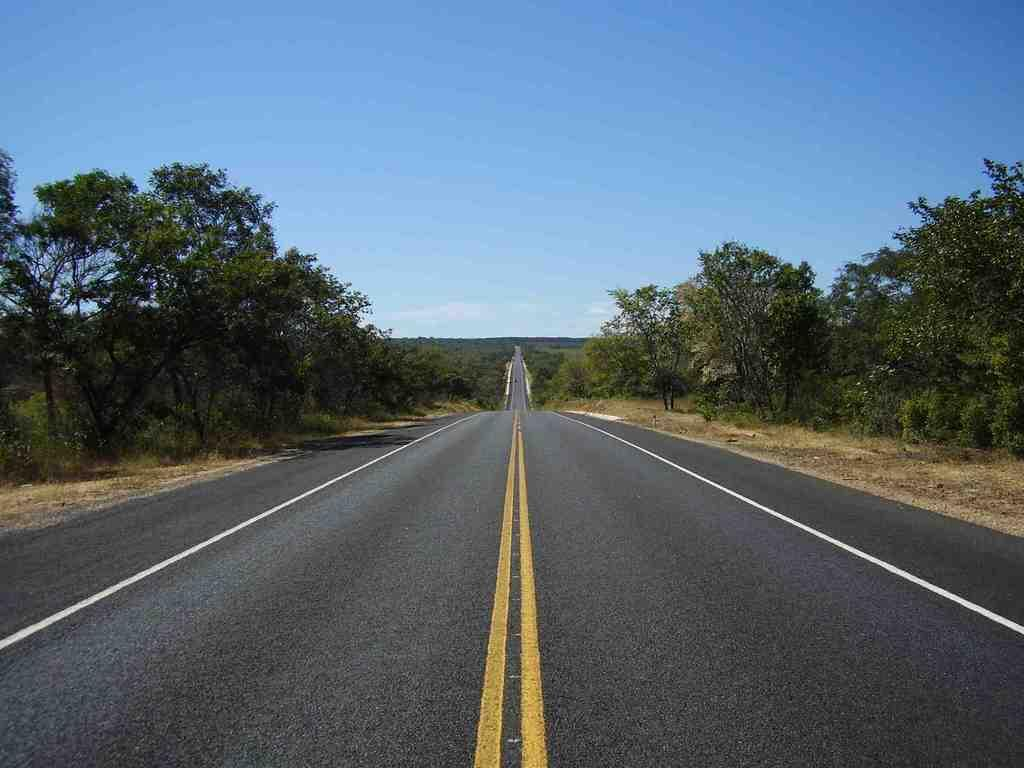What is the main feature in the middle of the image? There is a road in the middle of the image. What can be seen on either side of the road? Trees are present on either side of the road. What is visible at the top of the image? The sky is visible at the top of the image. What type of markings are on the road? There are lines on the road. What type of advertisement can be seen on someone's leg in the image? There is no advertisement or person with a leg visible in the image. 